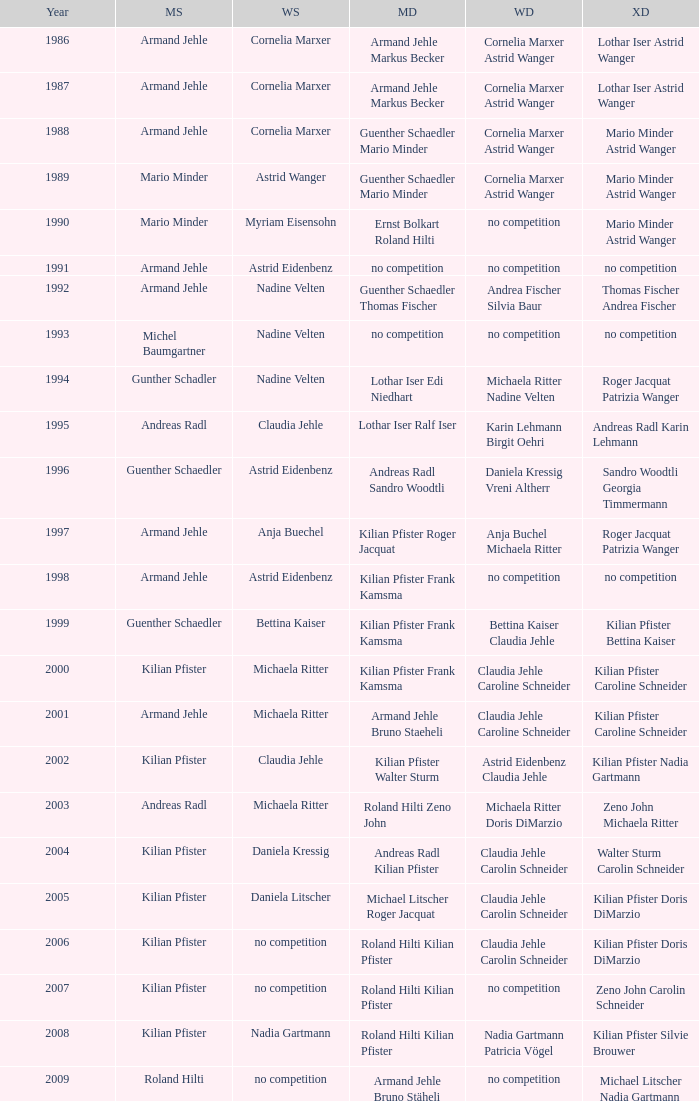In the year 2006, the womens singles had no competition and the mens doubles were roland hilti kilian pfister, what were the womens doubles Claudia Jehle Carolin Schneider. 